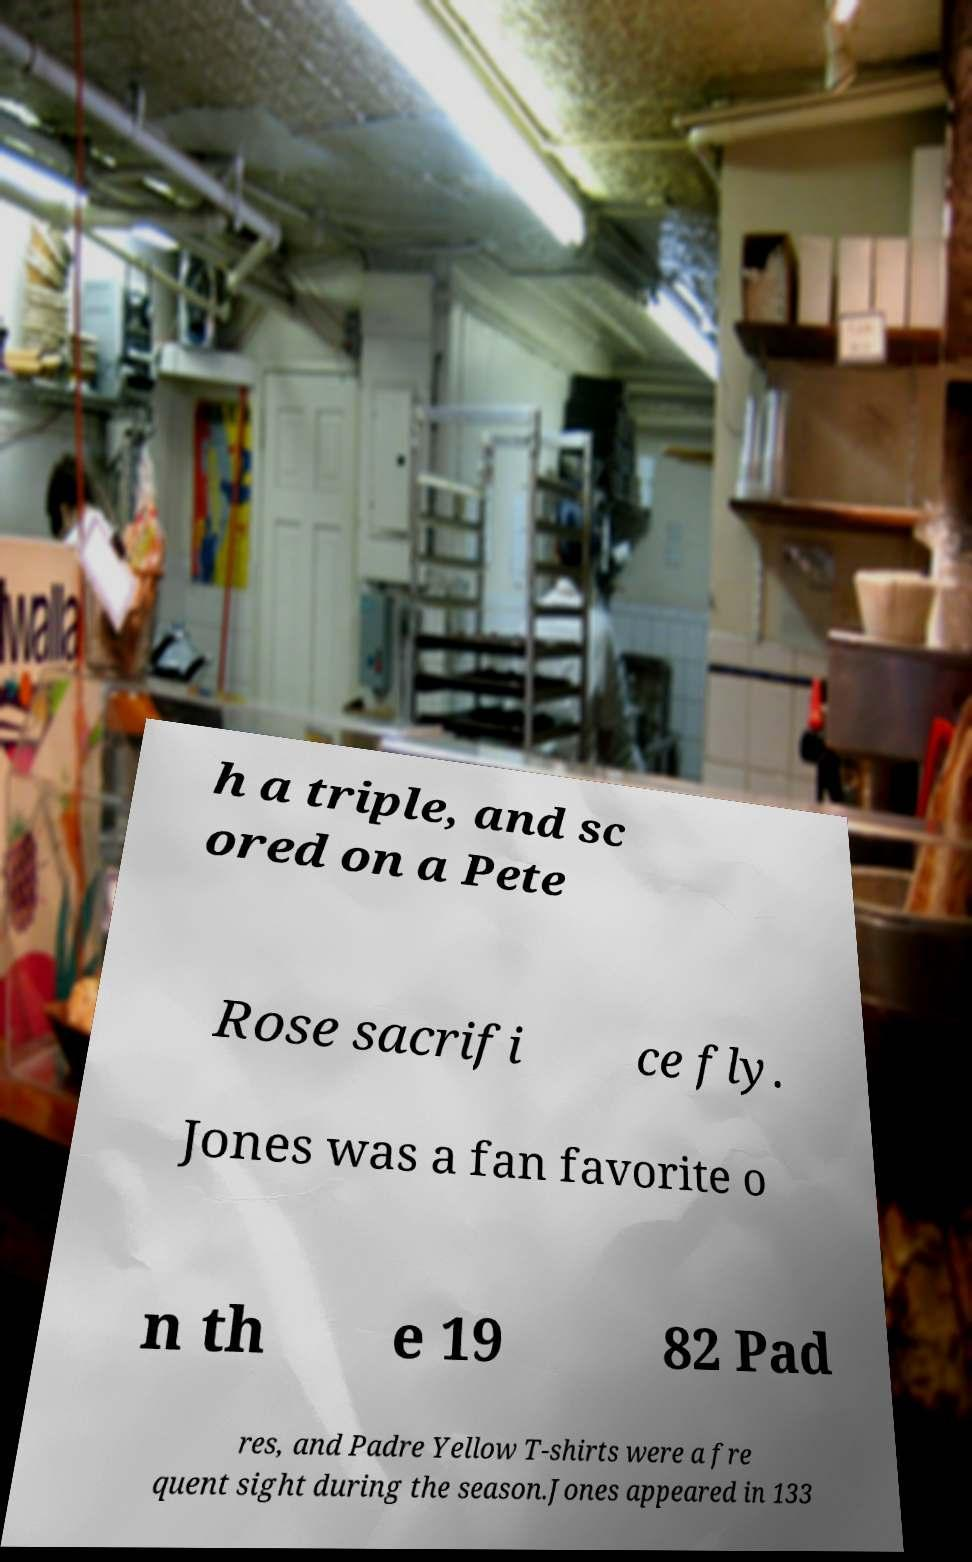Can you accurately transcribe the text from the provided image for me? h a triple, and sc ored on a Pete Rose sacrifi ce fly. Jones was a fan favorite o n th e 19 82 Pad res, and Padre Yellow T-shirts were a fre quent sight during the season.Jones appeared in 133 